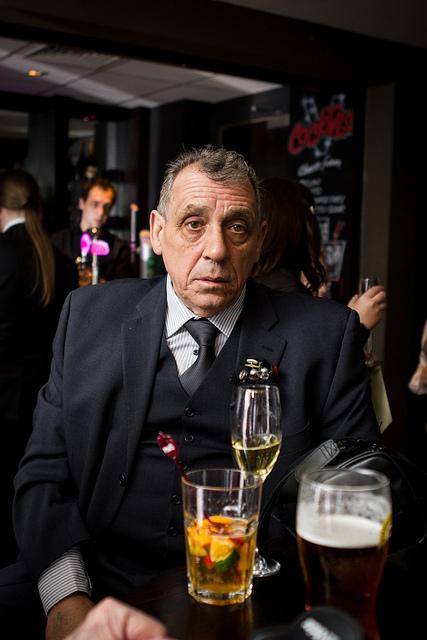Where do the glasses sit?
Answer briefly. On table. What kind of wine is he drinking?
Short answer required. White. Is he looking at the camera?
Short answer required. Yes. 